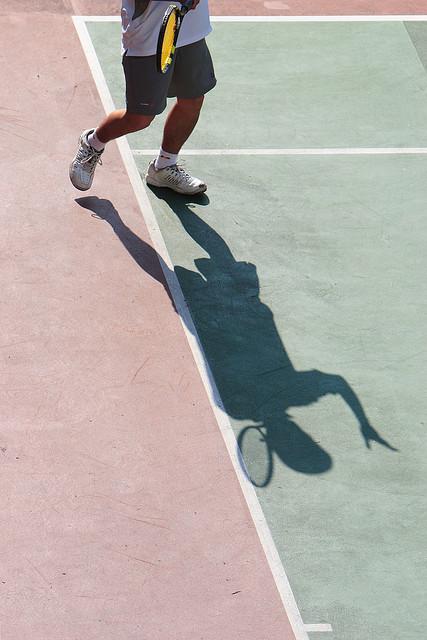What sport is the young man playing?
Quick response, please. Tennis. What is the man trying to hit?
Answer briefly. Tennis ball. What is he doing?
Keep it brief. Playing tennis. Where is the man located on the tennis court?
Be succinct. Yes. Are the persons knees scraped up?
Quick response, please. No. Does this person have on matching socks and shoes?
Answer briefly. Yes. What is this person doing?
Quick response, please. Playing tennis. What is cast?
Keep it brief. Shadow. What does the shadow in this image tell us about time of day?
Answer briefly. Daytime. 